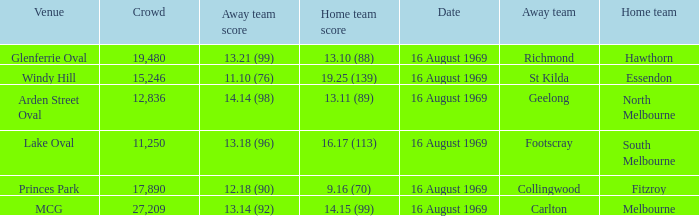When was the game played at Lake Oval? 16 August 1969. 